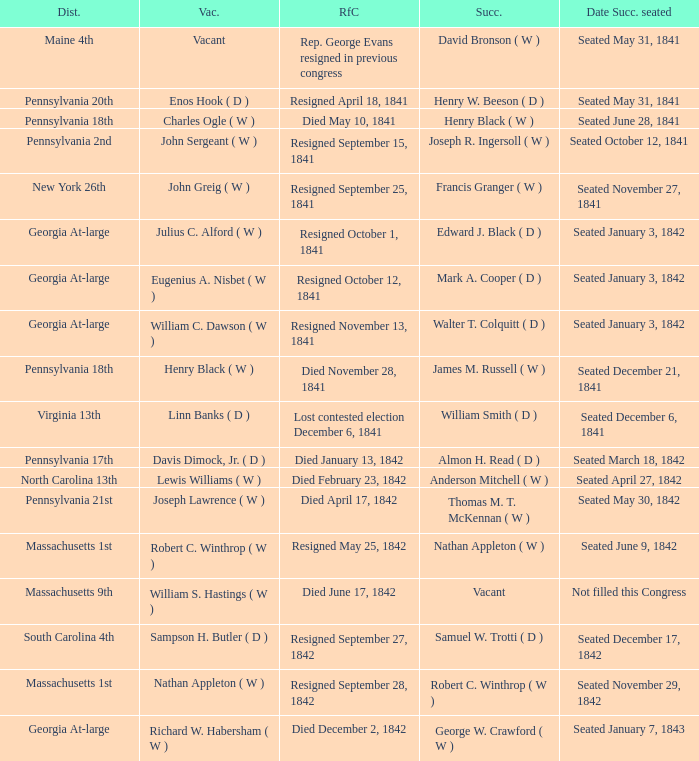Name the successor for north carolina 13th Anderson Mitchell ( W ). 